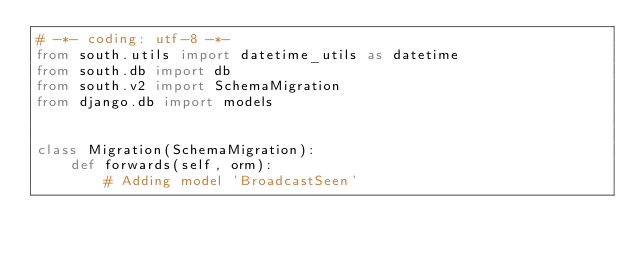Convert code to text. <code><loc_0><loc_0><loc_500><loc_500><_Python_># -*- coding: utf-8 -*-
from south.utils import datetime_utils as datetime
from south.db import db
from south.v2 import SchemaMigration
from django.db import models


class Migration(SchemaMigration):
    def forwards(self, orm):
        # Adding model 'BroadcastSeen'</code> 